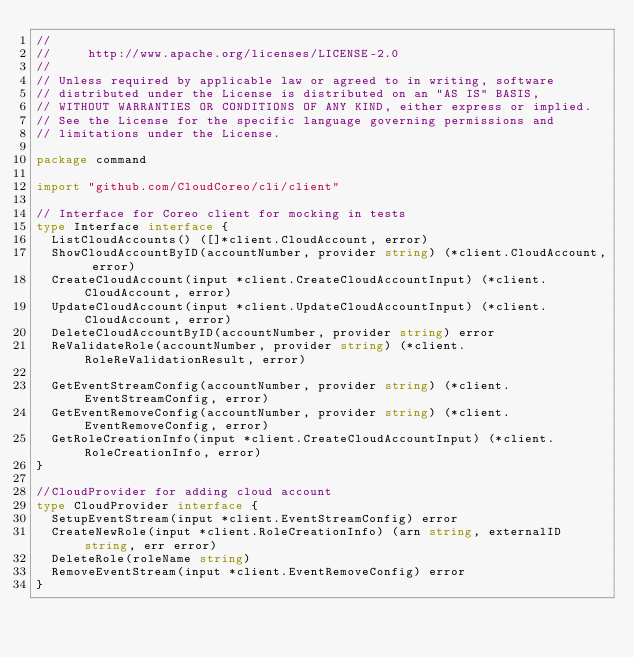Convert code to text. <code><loc_0><loc_0><loc_500><loc_500><_Go_>//
//     http://www.apache.org/licenses/LICENSE-2.0
//
// Unless required by applicable law or agreed to in writing, software
// distributed under the License is distributed on an "AS IS" BASIS,
// WITHOUT WARRANTIES OR CONDITIONS OF ANY KIND, either express or implied.
// See the License for the specific language governing permissions and
// limitations under the License.

package command

import "github.com/CloudCoreo/cli/client"

// Interface for Coreo client for mocking in tests
type Interface interface {
	ListCloudAccounts() ([]*client.CloudAccount, error)
	ShowCloudAccountByID(accountNumber, provider string) (*client.CloudAccount, error)
	CreateCloudAccount(input *client.CreateCloudAccountInput) (*client.CloudAccount, error)
	UpdateCloudAccount(input *client.UpdateCloudAccountInput) (*client.CloudAccount, error)
	DeleteCloudAccountByID(accountNumber, provider string) error
	ReValidateRole(accountNumber, provider string) (*client.RoleReValidationResult, error)

	GetEventStreamConfig(accountNumber, provider string) (*client.EventStreamConfig, error)
	GetEventRemoveConfig(accountNumber, provider string) (*client.EventRemoveConfig, error)
	GetRoleCreationInfo(input *client.CreateCloudAccountInput) (*client.RoleCreationInfo, error)
}

//CloudProvider for adding cloud account
type CloudProvider interface {
	SetupEventStream(input *client.EventStreamConfig) error
	CreateNewRole(input *client.RoleCreationInfo) (arn string, externalID string, err error)
	DeleteRole(roleName string)
	RemoveEventStream(input *client.EventRemoveConfig) error
}
</code> 